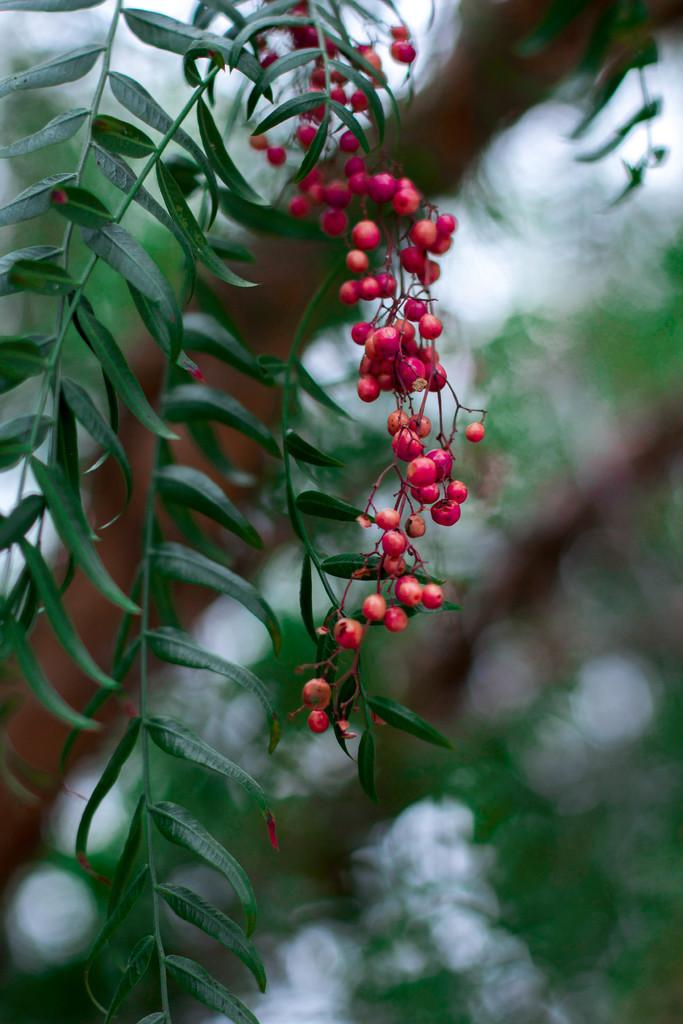What color are the fruits in the image? The fruits in the image are red. What can be seen in the background of the image? There are trees in green color in the background of the image. What color is the sky in the image? The sky is in white color in the image. What is the name of the person sitting on the seat in the image? There is no person or seat present in the image. 